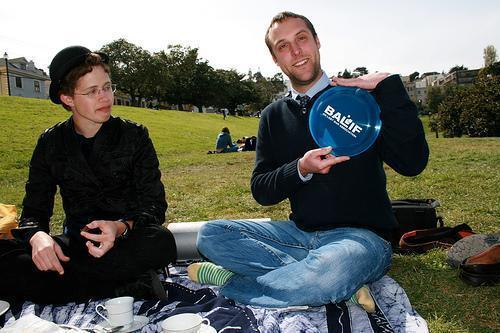How many people are visibly wearing glasses?
Give a very brief answer. 1. How many people holding a blue disc are in the picture?
Give a very brief answer. 1. 